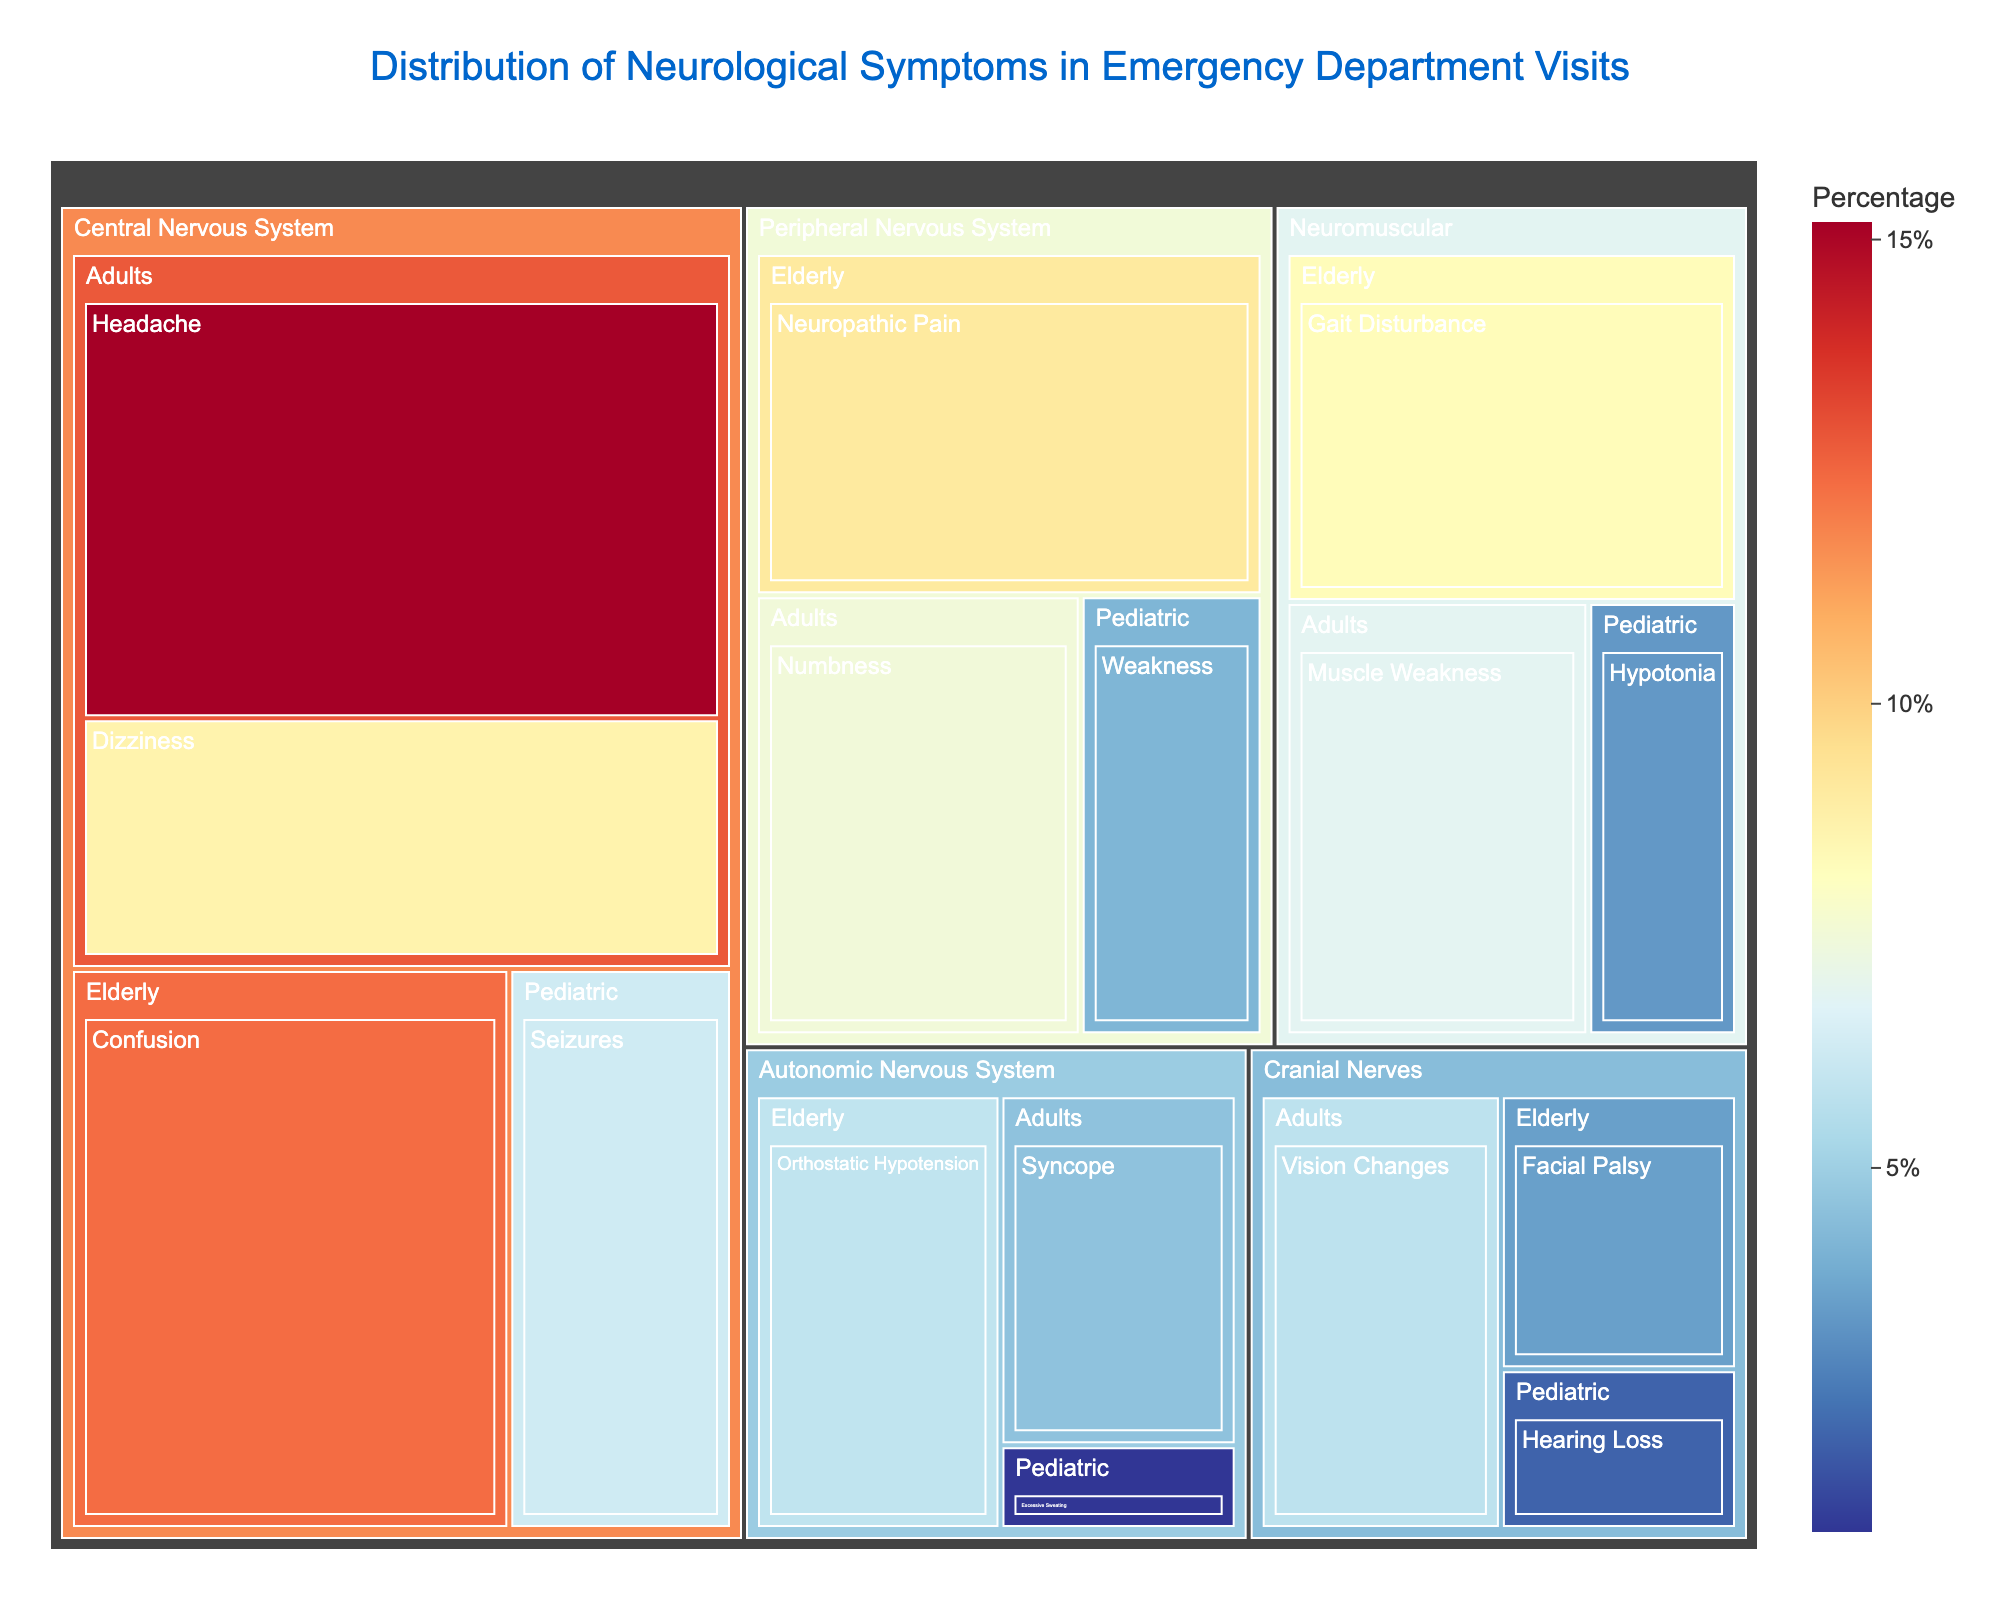What's the title of the figure? The title of the figure is typically the largest piece of text at the top of the graph, providing an immediate overview of what the figure represents. In this case, it is "Distribution of Neurological Symptoms in Emergency Department Visits".
Answer: Distribution of Neurological Symptoms in Emergency Department Visits Which symptom has the highest percentage within the "Central Nervous System" for the "Adults" age group? By examining the "Central Nervous System" section of the treemap specifically within the "Adults" age group, we can compare the percentages of different symptoms. "Headache" has the highest percentage at 15.2%.
Answer: Headache What is the percentage of "Gait Disturbance" in the "Neuromuscular" category for the "Elderly"? By locating the "Neuromuscular" section and then focusing on the "Elderly" age group, we can see that "Gait Disturbance" has its percentage listed as 8.3%.
Answer: 8.3% Compare the percentages of "Numbness" in "Peripheral Nervous System" for the "Adults" to "Hearing Loss" in "Cranial Nerves" for the "Pediatric". Which is greater? First, locate the "Peripheral Nervous System" -> "Adults" -> "Numbness" and note the percentage (7.5%). Next, locate the "Cranial Nerves" -> "Pediatric" -> "Hearing Loss" and note the percentage (2.1%). 7.5% is greater than 2.1%.
Answer: Numbness What is the combined percentage of "Confusion" in "Central Nervous System" for the "Elderly" and "Dizziness" in "Central Nervous System" for "Adults"? By finding the "Central Nervous System" section, we see "Confusion" in the "Elderly" has 12.4% and "Dizziness" in the "Adults" has 8.7%. Adding these values together, 12.4% + 8.7% = 21.1%.
Answer: 21.1% How does the percentage of "Syncope" in the "Autonomic Nervous System" for "Adults" compare to "Orthostatic Hypotension" in the same system for "Elderly"? In the "Autonomic Nervous System" section, find "Syncope" for "Adults" which has 4.6%, then compare it with "Orthostatic Hypotension" for "Elderly" which has 5.9%. 5.9% is greater than 4.6%.
Answer: Orthostatic Hypotension is greater Which body system and age group combination reports "Excessive Sweating" and what is its percentage? Find the specific symptom "Excessive Sweating" within the treemap. It falls under the "Autonomic Nervous System" for the "Pediatric" age group, with a percentage of 1.1%.
Answer: Autonomic Nervous System, Pediatric, 1.1% Identify the symptom with the lowest reported percentage overall and state its percentage. By scanning the entire treemap, we can identify the smallest value listed. "Excessive Sweating" in the "Autonomic Nervous System" for the "Pediatric" age group has the lowest percentage at 1.1%.
Answer: Excessive Sweating, 1.1% What are the symptoms reported in the "Cranial Nerves" category across all age groups and their respective percentages? Within the "Cranial Nerves" category of the treemap, identify each symptom and its percentage: "Vision Changes" in "Adults" (5.8%), "Facial Palsy" in "Elderly" (3.6%), and "Hearing Loss" in "Pediatric" (2.1%).
Answer: Vision Changes (5.8%), Facial Palsy (3.6%), Hearing Loss (2.1%) Is the percentage of "Seizures" in "Central Nervous System" for "Pediatric" higher or lower than "Vision Changes" in "Cranial Nerves" for "Adults"? Locate "Seizures" under "Central Nervous System" for "Pediatric" (6.3%) and compare it with "Vision Changes" under "Cranial Nerves" for "Adults" (5.8%). 6.3% is higher than 5.8%.
Answer: Higher 